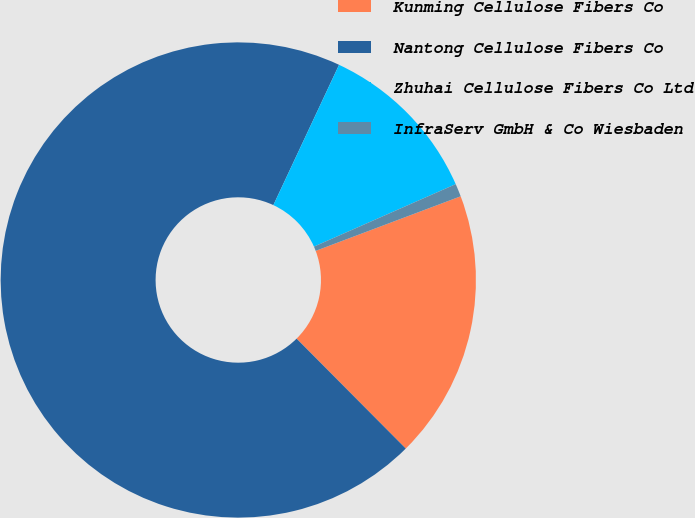<chart> <loc_0><loc_0><loc_500><loc_500><pie_chart><fcel>Kunming Cellulose Fibers Co<fcel>Nantong Cellulose Fibers Co<fcel>Zhuhai Cellulose Fibers Co Ltd<fcel>InfraServ GmbH & Co Wiesbaden<nl><fcel>18.28%<fcel>69.42%<fcel>11.42%<fcel>0.88%<nl></chart> 